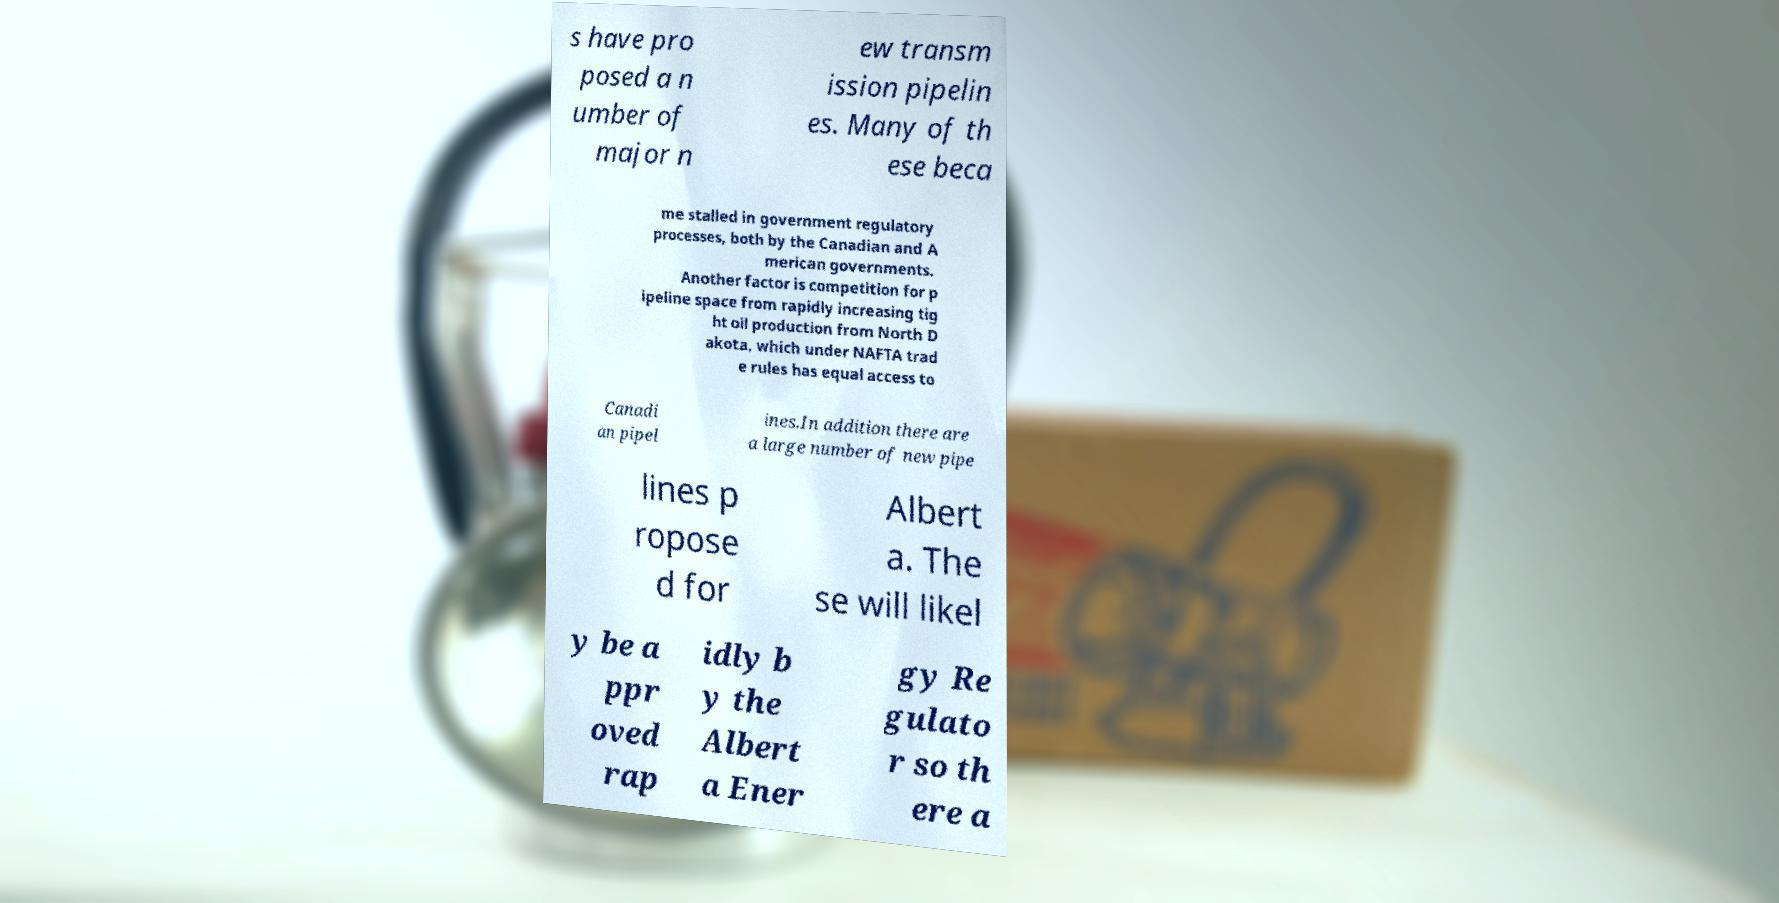Could you assist in decoding the text presented in this image and type it out clearly? s have pro posed a n umber of major n ew transm ission pipelin es. Many of th ese beca me stalled in government regulatory processes, both by the Canadian and A merican governments. Another factor is competition for p ipeline space from rapidly increasing tig ht oil production from North D akota, which under NAFTA trad e rules has equal access to Canadi an pipel ines.In addition there are a large number of new pipe lines p ropose d for Albert a. The se will likel y be a ppr oved rap idly b y the Albert a Ener gy Re gulato r so th ere a 